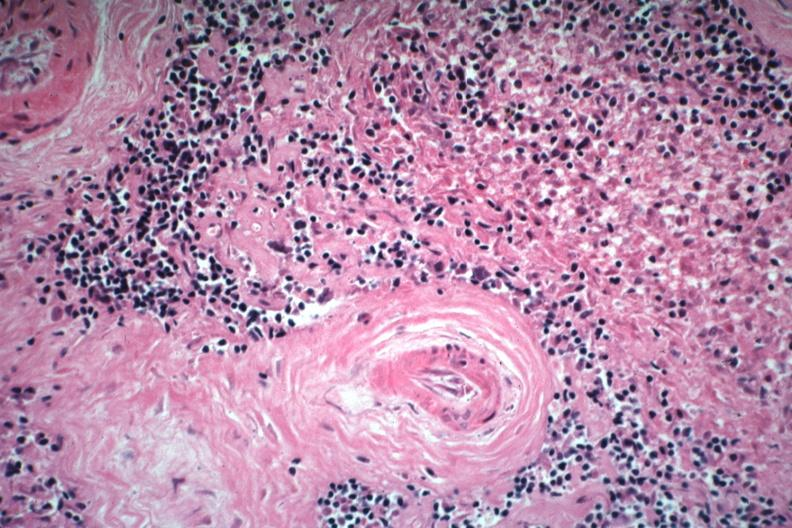what is present?
Answer the question using a single word or phrase. Spleen 